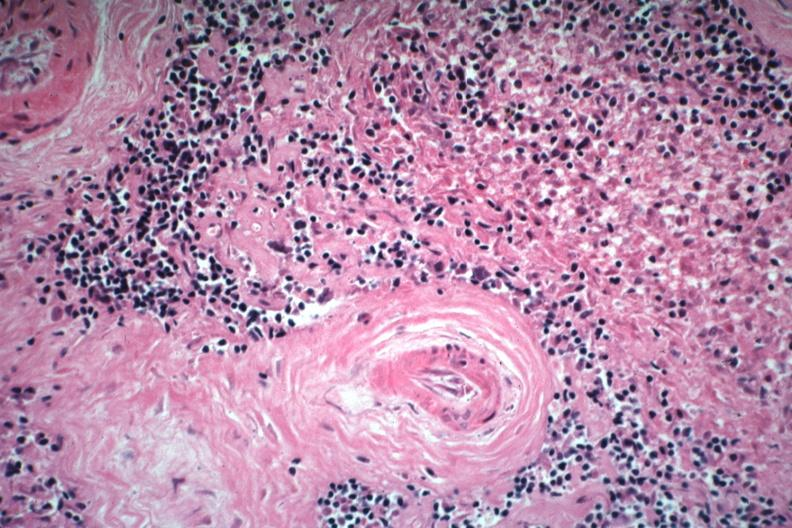what is present?
Answer the question using a single word or phrase. Spleen 